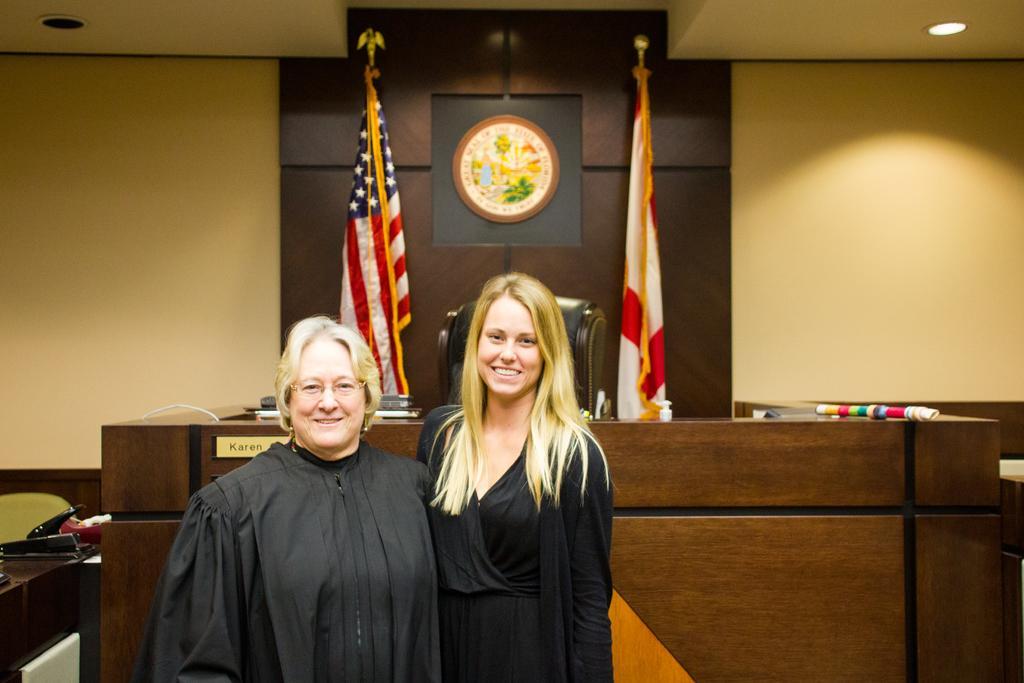Describe this image in one or two sentences. There are two women standing and wearing a black color dress at the bottom of this image. We can see a wooden thing in the background and there are two flags and a chair in the middle of this image. We can see a wall in the background. 